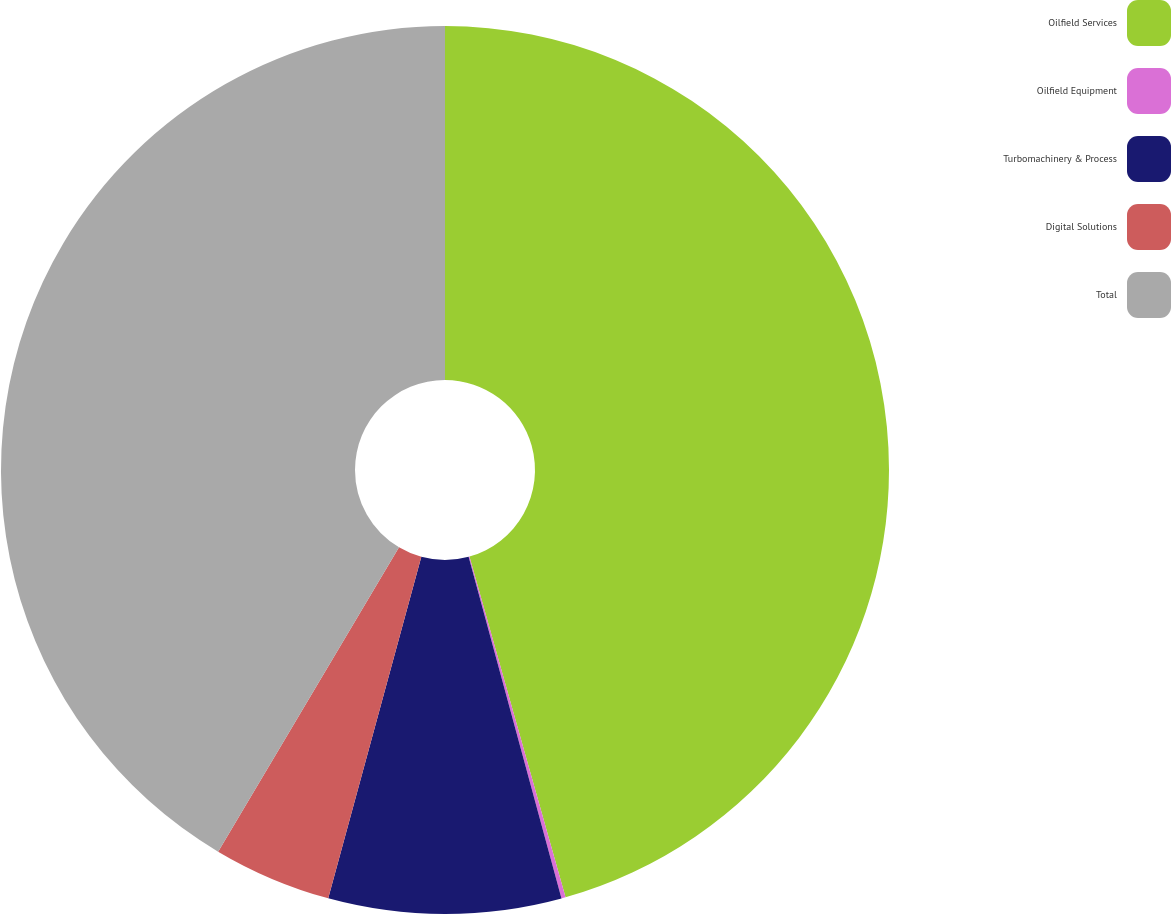<chart> <loc_0><loc_0><loc_500><loc_500><pie_chart><fcel>Oilfield Services<fcel>Oilfield Equipment<fcel>Turbomachinery & Process<fcel>Digital Solutions<fcel>Total<nl><fcel>45.62%<fcel>0.15%<fcel>8.46%<fcel>4.3%<fcel>41.46%<nl></chart> 